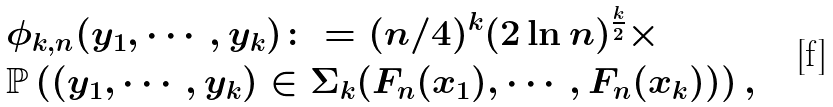<formula> <loc_0><loc_0><loc_500><loc_500>& \phi _ { k , n } ( y _ { 1 } , \cdots , y _ { k } ) \colon = ( n / 4 ) ^ { k } ( 2 \ln n ) ^ { \frac { k } { 2 } } \times \\ & \mathbb { P } \left ( ( y _ { 1 } , \cdots , y _ { k } ) \in \Sigma _ { k } ( F _ { n } ( x _ { 1 } ) , \cdots , F _ { n } ( x _ { k } ) ) \right ) ,</formula> 